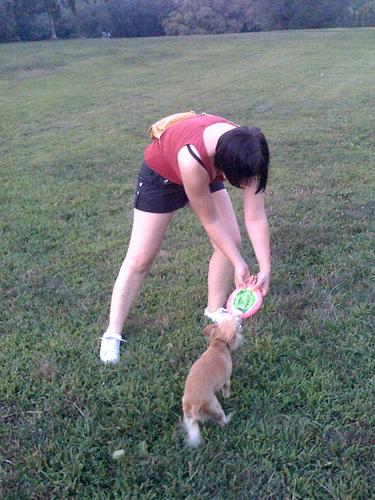What color is the frisbee?
Be succinct. Green. Is the woman sitting?
Quick response, please. No. What kind of shoes does she have on?
Give a very brief answer. Tennis. Can this dog catch a Frisbee?
Quick response, please. Yes. Did the dog just jump to get the object in it's mouth?
Answer briefly. No. What kind of animal is that?
Quick response, please. Dog. 